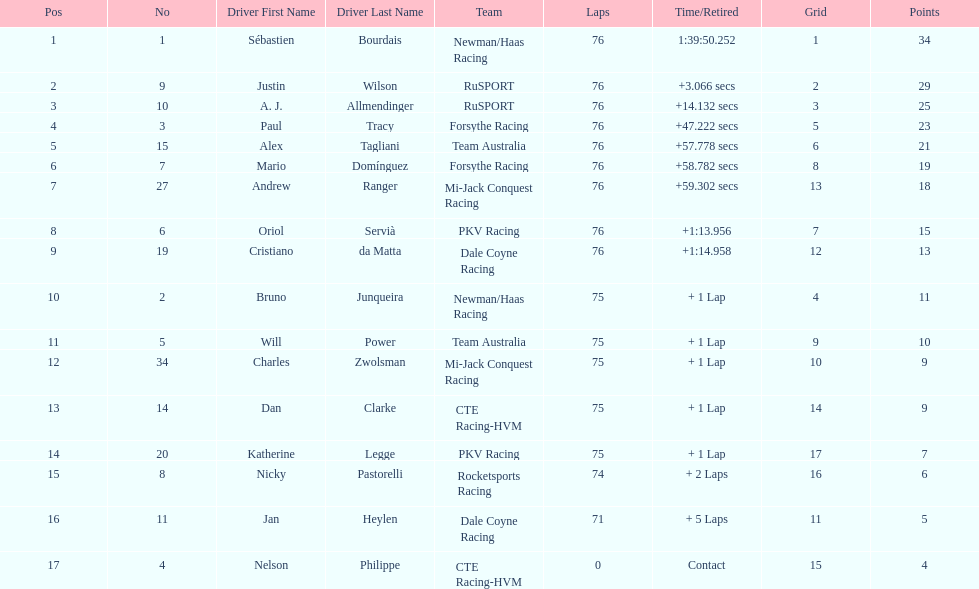Which canadian driver finished first: alex tagliani or paul tracy? Paul Tracy. 